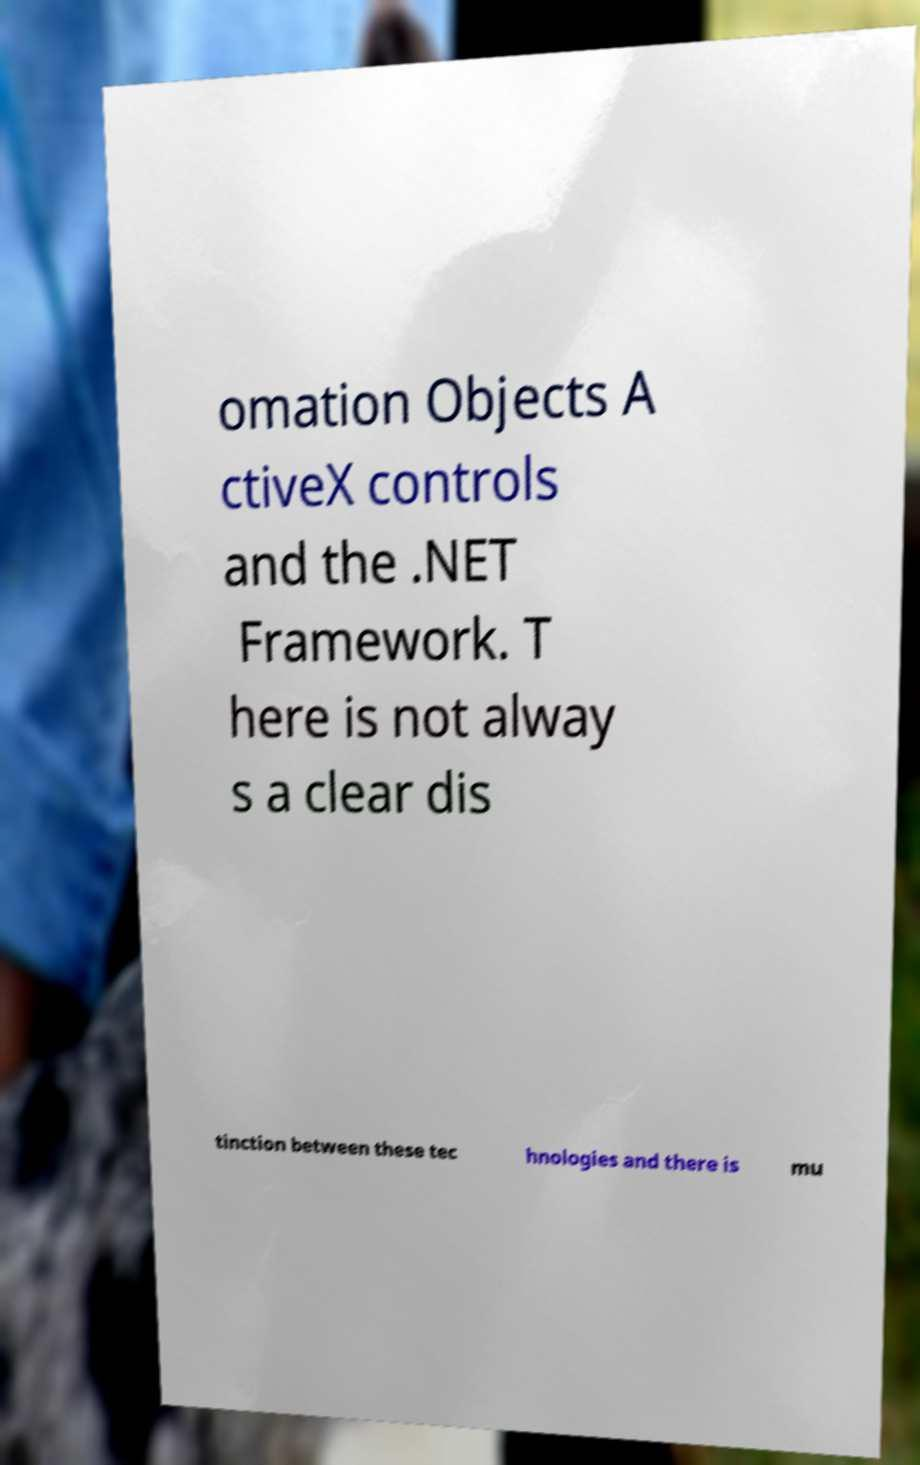Can you read and provide the text displayed in the image?This photo seems to have some interesting text. Can you extract and type it out for me? omation Objects A ctiveX controls and the .NET Framework. T here is not alway s a clear dis tinction between these tec hnologies and there is mu 